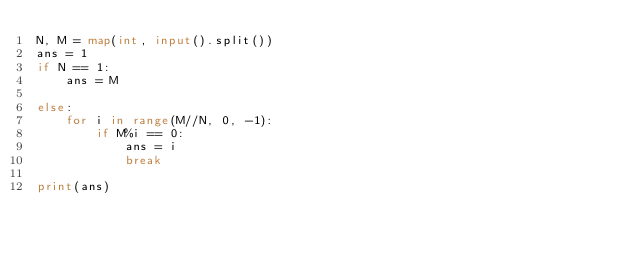Convert code to text. <code><loc_0><loc_0><loc_500><loc_500><_Python_>N, M = map(int, input().split())
ans = 1
if N == 1:
	ans = M

else:
	for i in range(M//N, 0, -1):
		if M%i == 0:
			ans = i
			break

print(ans)
</code> 